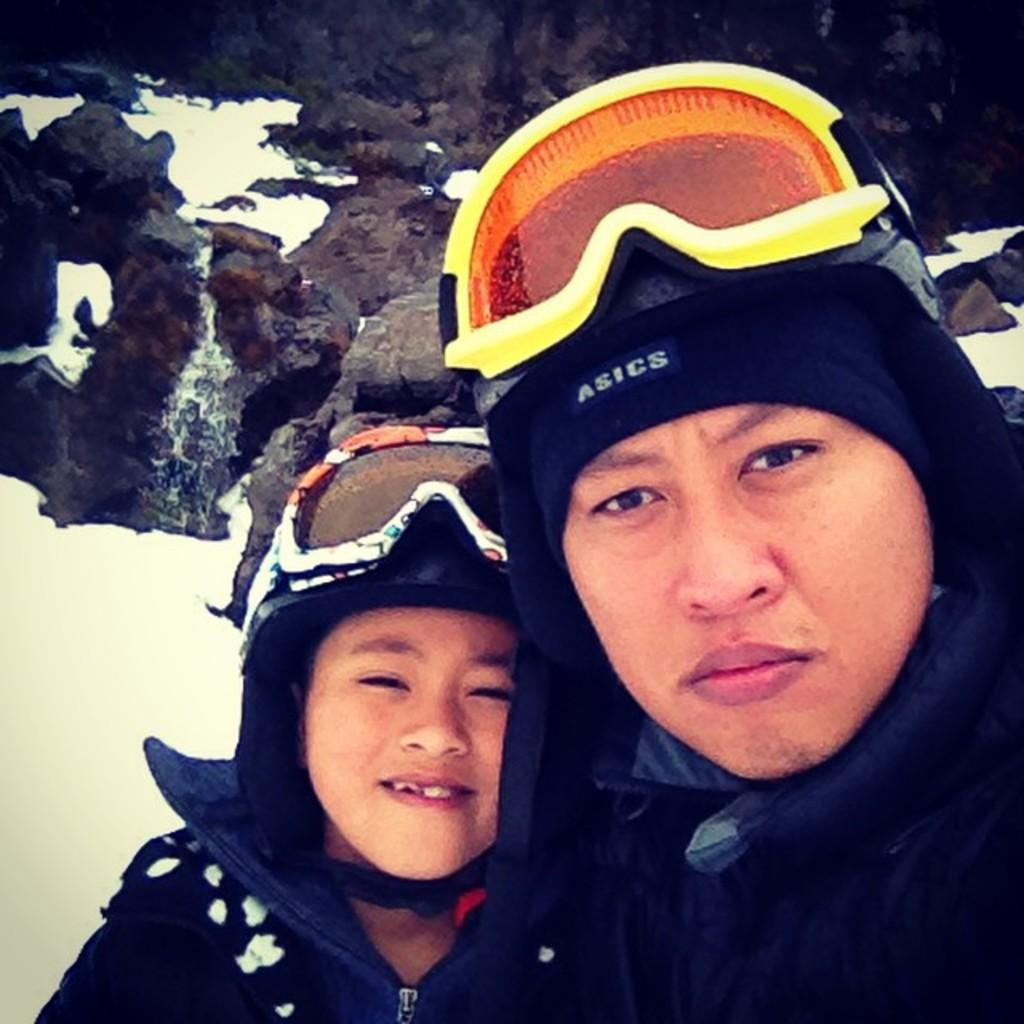How many people are in the image? There are two persons in the image. What are the persons doing in the image? The persons are standing and smiling. What can be seen in the background of the image? There are hills visible in the background of the image. What is the weather like in the image? The presence of snow in the image suggests a cold or wintery environment. What type of nut is being cracked by the person on the left in the image? There is no nut present in the image, and therefore no such activity can be observed. 